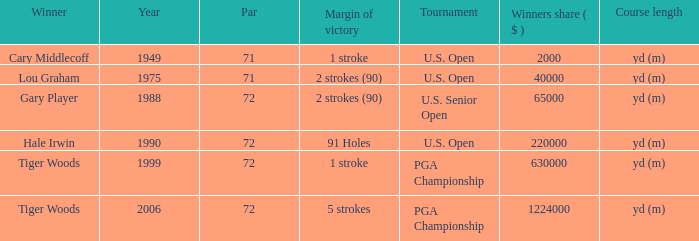When 1999 is the year how many tournaments are there? 1.0. 